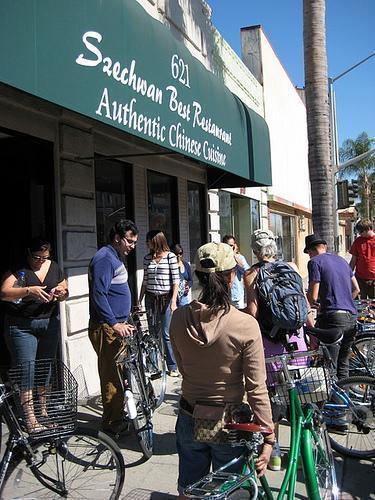What kind of food is most common in this restaurant?
Indicate the correct response by choosing from the four available options to answer the question.
Options: Spicy, taco, sandwich, curry. Spicy. 